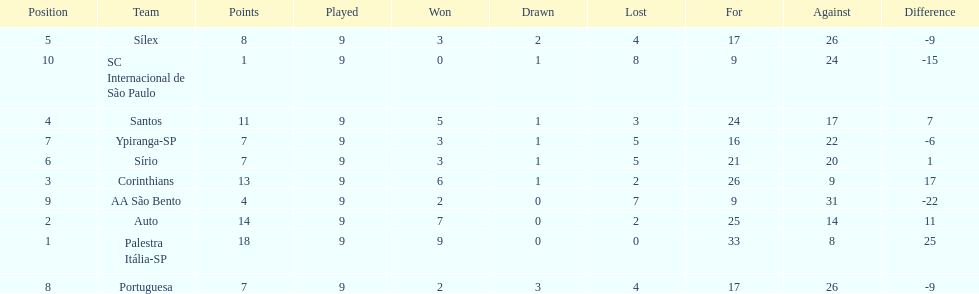Which is the only team to score 13 points in 9 games? Corinthians. 